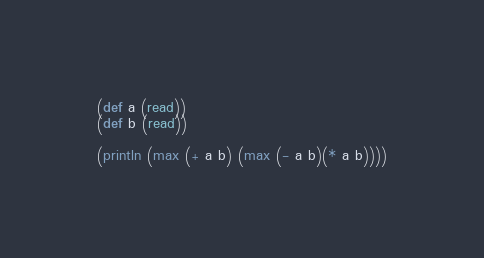<code> <loc_0><loc_0><loc_500><loc_500><_Clojure_>(def a (read))
(def b (read))

(println (max (+ a b) (max (- a b)(* a b))))</code> 